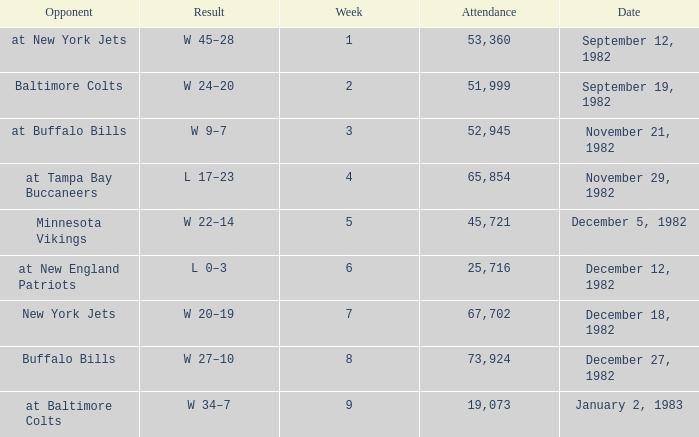What week was the game on September 12, 1982 with an attendance greater than 51,999? 1.0. 